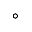<formula> <loc_0><loc_0><loc_500><loc_500>^ { \circ }</formula> 